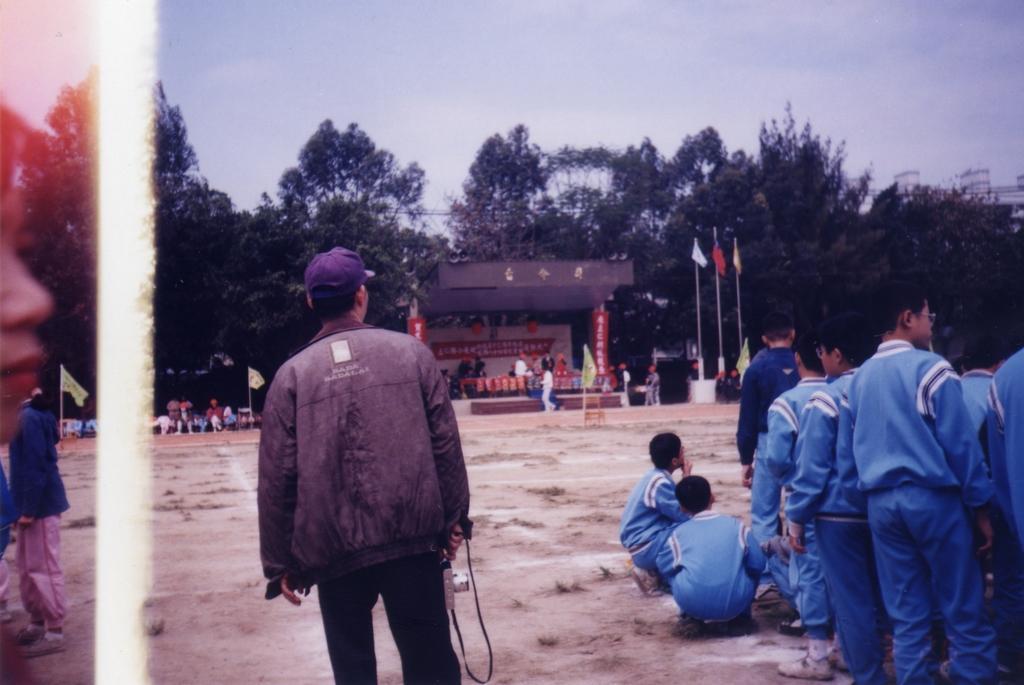Could you give a brief overview of what you see in this image? On the left side of the image we can see one human face and two persons. On the right side of the image we can see a few people are in different costumes. In the center of the image, we can see one person is standing and he is wearing a cap and a jacket. And we can see he is holding some object. In the background, we can see the sky, clouds, flags, banners, one stage, few people and a few other objects. 